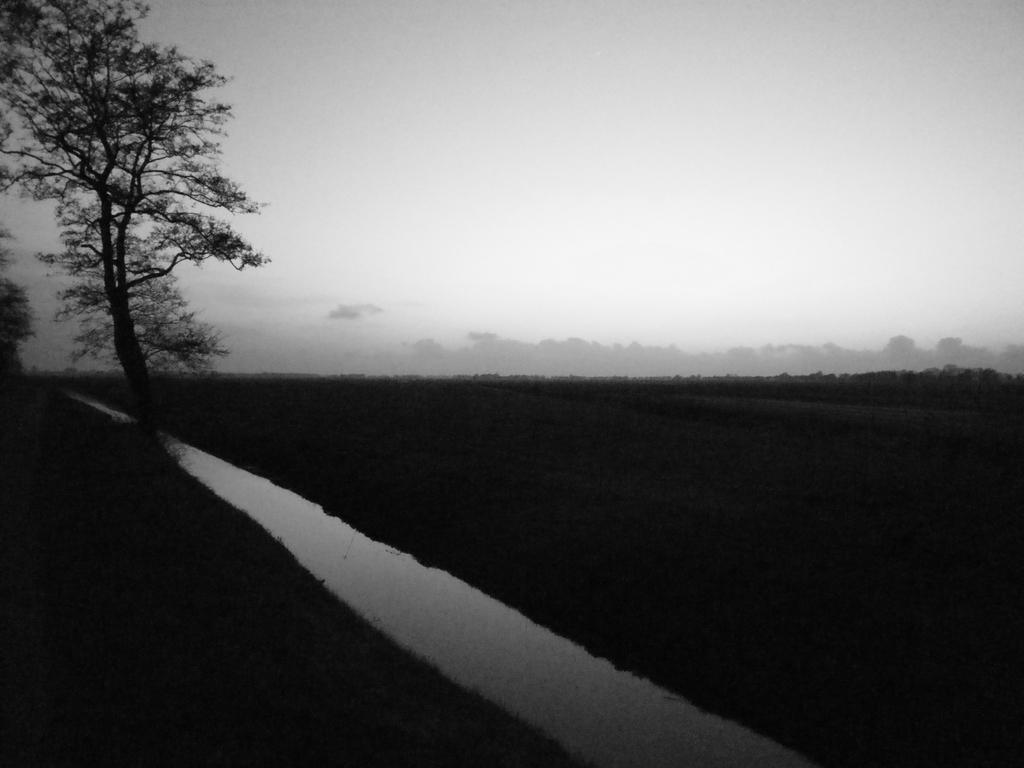What type of picture is in the image? The image contains a black and white picture. What is the main subject of the picture? The picture depicts the ground. What natural elements can be seen in the picture? There are trees and water in the picture. What part of the natural environment is visible in the background of the picture? The sky is visible in the background of the picture. Can you tell me how many pockets are visible in the picture? There are no pockets visible in the picture, as it is a black and white image of the ground, trees, water, and sky. Who is giving a kiss in the picture? There is no kiss depicted in the picture; it features a landscape with the ground, trees, water, and sky. 